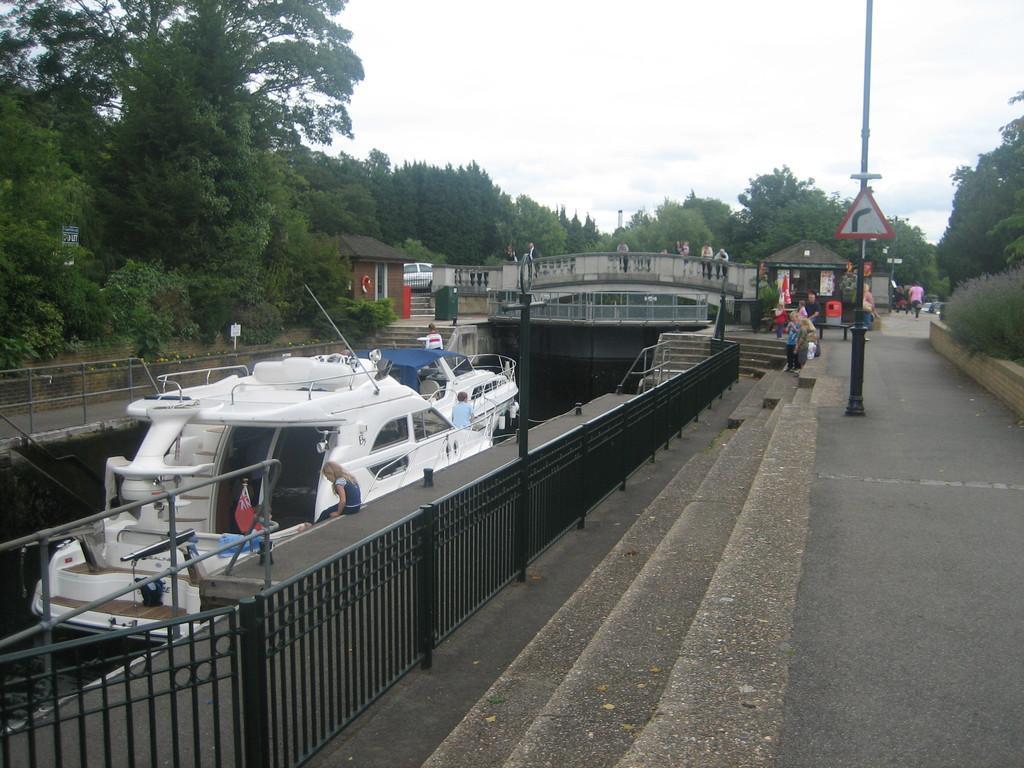Could you give a brief overview of what you see in this image? In the image there is a road and beside the road there is a river, a boat is sailing on the water. There is a bridge across the river, there are some people standing on the bridge and around the road there are many trees. 